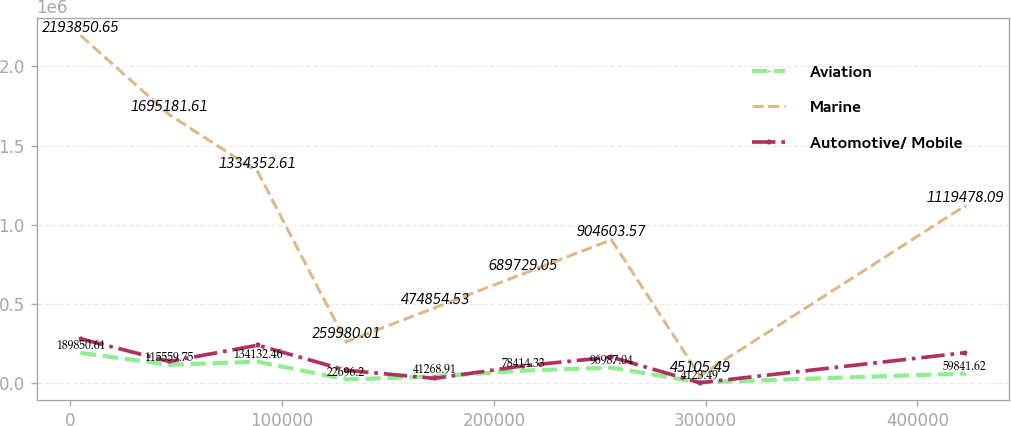Convert chart. <chart><loc_0><loc_0><loc_500><loc_500><line_chart><ecel><fcel>Aviation<fcel>Marine<fcel>Automotive/ Mobile<nl><fcel>4963.35<fcel>189851<fcel>2.19385e+06<fcel>278842<nl><fcel>46717<fcel>115560<fcel>1.69518e+06<fcel>135833<nl><fcel>88470.6<fcel>134132<fcel>1.33435e+06<fcel>238641<nl><fcel>130224<fcel>22696.2<fcel>259980<fcel>80351.4<nl><fcel>171978<fcel>41268.9<fcel>474855<fcel>29174.9<nl><fcel>213732<fcel>78414.3<fcel>689729<fcel>108092<nl><fcel>255485<fcel>96987<fcel>904604<fcel>163574<nl><fcel>297239<fcel>4123.49<fcel>45105.5<fcel>1434.15<nl><fcel>422500<fcel>59841.6<fcel>1.11948e+06<fcel>191314<nl></chart> 